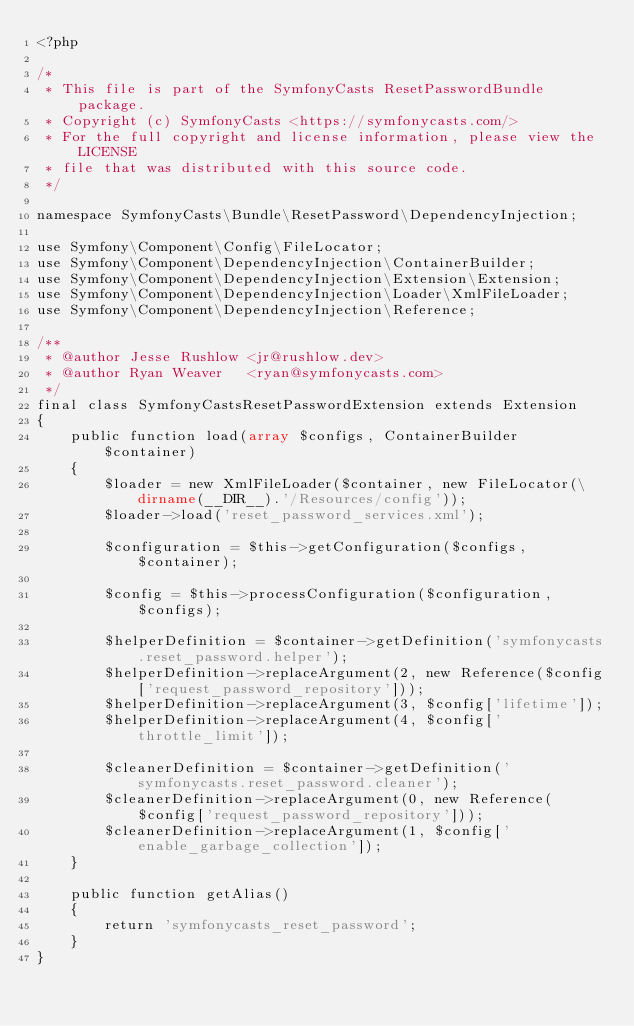Convert code to text. <code><loc_0><loc_0><loc_500><loc_500><_PHP_><?php

/*
 * This file is part of the SymfonyCasts ResetPasswordBundle package.
 * Copyright (c) SymfonyCasts <https://symfonycasts.com/>
 * For the full copyright and license information, please view the LICENSE
 * file that was distributed with this source code.
 */

namespace SymfonyCasts\Bundle\ResetPassword\DependencyInjection;

use Symfony\Component\Config\FileLocator;
use Symfony\Component\DependencyInjection\ContainerBuilder;
use Symfony\Component\DependencyInjection\Extension\Extension;
use Symfony\Component\DependencyInjection\Loader\XmlFileLoader;
use Symfony\Component\DependencyInjection\Reference;

/**
 * @author Jesse Rushlow <jr@rushlow.dev>
 * @author Ryan Weaver   <ryan@symfonycasts.com>
 */
final class SymfonyCastsResetPasswordExtension extends Extension
{
    public function load(array $configs, ContainerBuilder $container)
    {
        $loader = new XmlFileLoader($container, new FileLocator(\dirname(__DIR__).'/Resources/config'));
        $loader->load('reset_password_services.xml');

        $configuration = $this->getConfiguration($configs, $container);

        $config = $this->processConfiguration($configuration, $configs);

        $helperDefinition = $container->getDefinition('symfonycasts.reset_password.helper');
        $helperDefinition->replaceArgument(2, new Reference($config['request_password_repository']));
        $helperDefinition->replaceArgument(3, $config['lifetime']);
        $helperDefinition->replaceArgument(4, $config['throttle_limit']);

        $cleanerDefinition = $container->getDefinition('symfonycasts.reset_password.cleaner');
        $cleanerDefinition->replaceArgument(0, new Reference($config['request_password_repository']));
        $cleanerDefinition->replaceArgument(1, $config['enable_garbage_collection']);
    }

    public function getAlias()
    {
        return 'symfonycasts_reset_password';
    }
}
</code> 